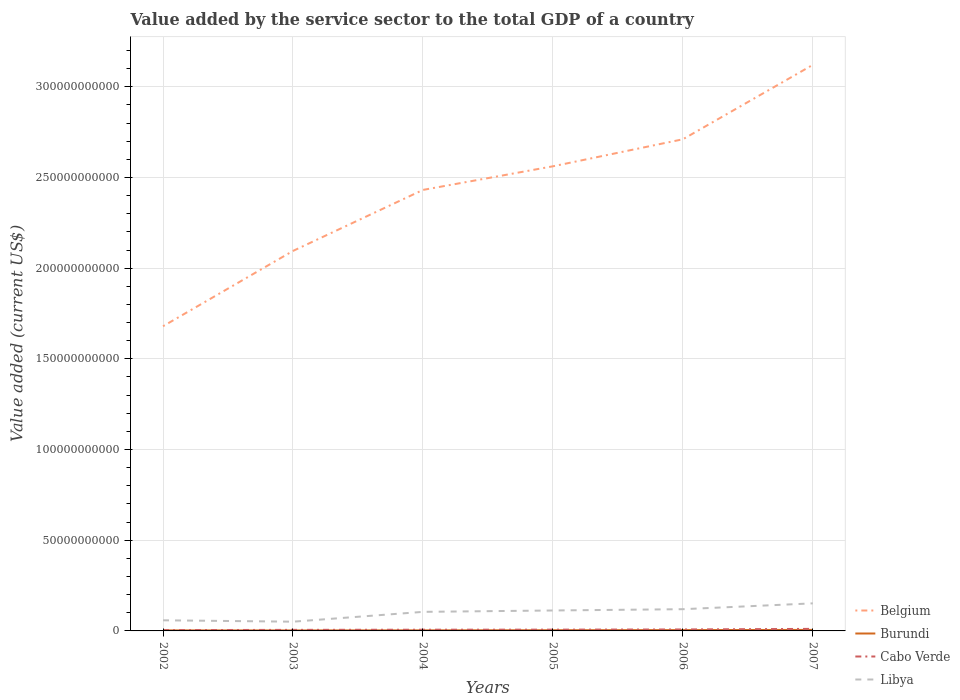Across all years, what is the maximum value added by the service sector to the total GDP in Cabo Verde?
Keep it short and to the point. 4.38e+08. What is the total value added by the service sector to the total GDP in Cabo Verde in the graph?
Offer a terse response. -3.30e+07. What is the difference between the highest and the second highest value added by the service sector to the total GDP in Libya?
Offer a terse response. 1.01e+1. What is the difference between the highest and the lowest value added by the service sector to the total GDP in Belgium?
Your answer should be compact. 3. How many lines are there?
Your answer should be compact. 4. How many years are there in the graph?
Your answer should be very brief. 6. What is the difference between two consecutive major ticks on the Y-axis?
Give a very brief answer. 5.00e+1. Does the graph contain grids?
Provide a succinct answer. Yes. How many legend labels are there?
Give a very brief answer. 4. What is the title of the graph?
Offer a terse response. Value added by the service sector to the total GDP of a country. Does "Chile" appear as one of the legend labels in the graph?
Your answer should be very brief. No. What is the label or title of the X-axis?
Provide a short and direct response. Years. What is the label or title of the Y-axis?
Your answer should be compact. Value added (current US$). What is the Value added (current US$) of Belgium in 2002?
Give a very brief answer. 1.68e+11. What is the Value added (current US$) in Burundi in 2002?
Provide a short and direct response. 2.93e+08. What is the Value added (current US$) of Cabo Verde in 2002?
Provide a short and direct response. 4.38e+08. What is the Value added (current US$) in Libya in 2002?
Provide a short and direct response. 5.86e+09. What is the Value added (current US$) of Belgium in 2003?
Your answer should be very brief. 2.10e+11. What is the Value added (current US$) in Burundi in 2003?
Ensure brevity in your answer.  2.65e+08. What is the Value added (current US$) in Cabo Verde in 2003?
Offer a terse response. 5.81e+08. What is the Value added (current US$) in Libya in 2003?
Keep it short and to the point. 5.09e+09. What is the Value added (current US$) of Belgium in 2004?
Your answer should be very brief. 2.43e+11. What is the Value added (current US$) in Burundi in 2004?
Provide a succinct answer. 3.11e+08. What is the Value added (current US$) of Cabo Verde in 2004?
Your answer should be compact. 6.65e+08. What is the Value added (current US$) of Libya in 2004?
Your answer should be very brief. 1.05e+1. What is the Value added (current US$) in Belgium in 2005?
Offer a very short reply. 2.56e+11. What is the Value added (current US$) in Burundi in 2005?
Provide a short and direct response. 3.80e+08. What is the Value added (current US$) of Cabo Verde in 2005?
Your answer should be compact. 6.98e+08. What is the Value added (current US$) in Libya in 2005?
Provide a short and direct response. 1.13e+1. What is the Value added (current US$) in Belgium in 2006?
Ensure brevity in your answer.  2.71e+11. What is the Value added (current US$) of Burundi in 2006?
Give a very brief answer. 4.54e+08. What is the Value added (current US$) in Cabo Verde in 2006?
Offer a terse response. 8.04e+08. What is the Value added (current US$) in Libya in 2006?
Provide a succinct answer. 1.20e+1. What is the Value added (current US$) of Belgium in 2007?
Provide a succinct answer. 3.12e+11. What is the Value added (current US$) in Burundi in 2007?
Offer a terse response. 5.57e+08. What is the Value added (current US$) of Cabo Verde in 2007?
Your response must be concise. 1.13e+09. What is the Value added (current US$) of Libya in 2007?
Provide a succinct answer. 1.52e+1. Across all years, what is the maximum Value added (current US$) in Belgium?
Give a very brief answer. 3.12e+11. Across all years, what is the maximum Value added (current US$) of Burundi?
Ensure brevity in your answer.  5.57e+08. Across all years, what is the maximum Value added (current US$) in Cabo Verde?
Offer a terse response. 1.13e+09. Across all years, what is the maximum Value added (current US$) of Libya?
Provide a succinct answer. 1.52e+1. Across all years, what is the minimum Value added (current US$) in Belgium?
Ensure brevity in your answer.  1.68e+11. Across all years, what is the minimum Value added (current US$) in Burundi?
Provide a short and direct response. 2.65e+08. Across all years, what is the minimum Value added (current US$) of Cabo Verde?
Provide a short and direct response. 4.38e+08. Across all years, what is the minimum Value added (current US$) of Libya?
Provide a succinct answer. 5.09e+09. What is the total Value added (current US$) in Belgium in the graph?
Keep it short and to the point. 1.46e+12. What is the total Value added (current US$) in Burundi in the graph?
Provide a succinct answer. 2.26e+09. What is the total Value added (current US$) in Cabo Verde in the graph?
Offer a very short reply. 4.31e+09. What is the total Value added (current US$) of Libya in the graph?
Offer a very short reply. 5.99e+1. What is the difference between the Value added (current US$) in Belgium in 2002 and that in 2003?
Offer a very short reply. -4.15e+1. What is the difference between the Value added (current US$) of Burundi in 2002 and that in 2003?
Make the answer very short. 2.76e+07. What is the difference between the Value added (current US$) of Cabo Verde in 2002 and that in 2003?
Make the answer very short. -1.42e+08. What is the difference between the Value added (current US$) in Libya in 2002 and that in 2003?
Give a very brief answer. 7.65e+08. What is the difference between the Value added (current US$) of Belgium in 2002 and that in 2004?
Your answer should be very brief. -7.52e+1. What is the difference between the Value added (current US$) in Burundi in 2002 and that in 2004?
Make the answer very short. -1.79e+07. What is the difference between the Value added (current US$) of Cabo Verde in 2002 and that in 2004?
Provide a short and direct response. -2.26e+08. What is the difference between the Value added (current US$) in Libya in 2002 and that in 2004?
Offer a terse response. -4.65e+09. What is the difference between the Value added (current US$) of Belgium in 2002 and that in 2005?
Offer a terse response. -8.82e+1. What is the difference between the Value added (current US$) of Burundi in 2002 and that in 2005?
Ensure brevity in your answer.  -8.69e+07. What is the difference between the Value added (current US$) in Cabo Verde in 2002 and that in 2005?
Your response must be concise. -2.59e+08. What is the difference between the Value added (current US$) in Libya in 2002 and that in 2005?
Provide a short and direct response. -5.41e+09. What is the difference between the Value added (current US$) of Belgium in 2002 and that in 2006?
Ensure brevity in your answer.  -1.03e+11. What is the difference between the Value added (current US$) in Burundi in 2002 and that in 2006?
Your response must be concise. -1.61e+08. What is the difference between the Value added (current US$) in Cabo Verde in 2002 and that in 2006?
Give a very brief answer. -3.66e+08. What is the difference between the Value added (current US$) of Libya in 2002 and that in 2006?
Offer a very short reply. -6.12e+09. What is the difference between the Value added (current US$) of Belgium in 2002 and that in 2007?
Ensure brevity in your answer.  -1.44e+11. What is the difference between the Value added (current US$) of Burundi in 2002 and that in 2007?
Provide a short and direct response. -2.64e+08. What is the difference between the Value added (current US$) of Cabo Verde in 2002 and that in 2007?
Offer a terse response. -6.91e+08. What is the difference between the Value added (current US$) of Libya in 2002 and that in 2007?
Provide a succinct answer. -9.34e+09. What is the difference between the Value added (current US$) in Belgium in 2003 and that in 2004?
Give a very brief answer. -3.36e+1. What is the difference between the Value added (current US$) in Burundi in 2003 and that in 2004?
Ensure brevity in your answer.  -4.56e+07. What is the difference between the Value added (current US$) in Cabo Verde in 2003 and that in 2004?
Give a very brief answer. -8.42e+07. What is the difference between the Value added (current US$) in Libya in 2003 and that in 2004?
Offer a very short reply. -5.42e+09. What is the difference between the Value added (current US$) of Belgium in 2003 and that in 2005?
Provide a succinct answer. -4.67e+1. What is the difference between the Value added (current US$) of Burundi in 2003 and that in 2005?
Make the answer very short. -1.15e+08. What is the difference between the Value added (current US$) in Cabo Verde in 2003 and that in 2005?
Your answer should be very brief. -1.17e+08. What is the difference between the Value added (current US$) of Libya in 2003 and that in 2005?
Keep it short and to the point. -6.18e+09. What is the difference between the Value added (current US$) of Belgium in 2003 and that in 2006?
Offer a terse response. -6.16e+1. What is the difference between the Value added (current US$) in Burundi in 2003 and that in 2006?
Provide a short and direct response. -1.89e+08. What is the difference between the Value added (current US$) of Cabo Verde in 2003 and that in 2006?
Your answer should be compact. -2.24e+08. What is the difference between the Value added (current US$) in Libya in 2003 and that in 2006?
Provide a short and direct response. -6.89e+09. What is the difference between the Value added (current US$) in Belgium in 2003 and that in 2007?
Your answer should be compact. -1.03e+11. What is the difference between the Value added (current US$) in Burundi in 2003 and that in 2007?
Your response must be concise. -2.91e+08. What is the difference between the Value added (current US$) in Cabo Verde in 2003 and that in 2007?
Provide a succinct answer. -5.48e+08. What is the difference between the Value added (current US$) in Libya in 2003 and that in 2007?
Provide a succinct answer. -1.01e+1. What is the difference between the Value added (current US$) of Belgium in 2004 and that in 2005?
Make the answer very short. -1.30e+1. What is the difference between the Value added (current US$) of Burundi in 2004 and that in 2005?
Provide a short and direct response. -6.90e+07. What is the difference between the Value added (current US$) in Cabo Verde in 2004 and that in 2005?
Make the answer very short. -3.30e+07. What is the difference between the Value added (current US$) in Libya in 2004 and that in 2005?
Offer a very short reply. -7.60e+08. What is the difference between the Value added (current US$) of Belgium in 2004 and that in 2006?
Your response must be concise. -2.79e+1. What is the difference between the Value added (current US$) of Burundi in 2004 and that in 2006?
Make the answer very short. -1.43e+08. What is the difference between the Value added (current US$) in Cabo Verde in 2004 and that in 2006?
Provide a succinct answer. -1.39e+08. What is the difference between the Value added (current US$) in Libya in 2004 and that in 2006?
Provide a short and direct response. -1.47e+09. What is the difference between the Value added (current US$) of Belgium in 2004 and that in 2007?
Provide a short and direct response. -6.90e+1. What is the difference between the Value added (current US$) of Burundi in 2004 and that in 2007?
Make the answer very short. -2.46e+08. What is the difference between the Value added (current US$) in Cabo Verde in 2004 and that in 2007?
Provide a succinct answer. -4.64e+08. What is the difference between the Value added (current US$) in Libya in 2004 and that in 2007?
Your answer should be very brief. -4.69e+09. What is the difference between the Value added (current US$) in Belgium in 2005 and that in 2006?
Ensure brevity in your answer.  -1.49e+1. What is the difference between the Value added (current US$) in Burundi in 2005 and that in 2006?
Ensure brevity in your answer.  -7.45e+07. What is the difference between the Value added (current US$) in Cabo Verde in 2005 and that in 2006?
Offer a very short reply. -1.06e+08. What is the difference between the Value added (current US$) of Libya in 2005 and that in 2006?
Provide a short and direct response. -7.10e+08. What is the difference between the Value added (current US$) of Belgium in 2005 and that in 2007?
Your answer should be compact. -5.59e+1. What is the difference between the Value added (current US$) of Burundi in 2005 and that in 2007?
Give a very brief answer. -1.77e+08. What is the difference between the Value added (current US$) in Cabo Verde in 2005 and that in 2007?
Give a very brief answer. -4.31e+08. What is the difference between the Value added (current US$) in Libya in 2005 and that in 2007?
Offer a terse response. -3.93e+09. What is the difference between the Value added (current US$) in Belgium in 2006 and that in 2007?
Your answer should be compact. -4.10e+1. What is the difference between the Value added (current US$) in Burundi in 2006 and that in 2007?
Give a very brief answer. -1.02e+08. What is the difference between the Value added (current US$) of Cabo Verde in 2006 and that in 2007?
Your answer should be very brief. -3.25e+08. What is the difference between the Value added (current US$) in Libya in 2006 and that in 2007?
Ensure brevity in your answer.  -3.22e+09. What is the difference between the Value added (current US$) in Belgium in 2002 and the Value added (current US$) in Burundi in 2003?
Make the answer very short. 1.68e+11. What is the difference between the Value added (current US$) of Belgium in 2002 and the Value added (current US$) of Cabo Verde in 2003?
Make the answer very short. 1.67e+11. What is the difference between the Value added (current US$) in Belgium in 2002 and the Value added (current US$) in Libya in 2003?
Your response must be concise. 1.63e+11. What is the difference between the Value added (current US$) in Burundi in 2002 and the Value added (current US$) in Cabo Verde in 2003?
Give a very brief answer. -2.88e+08. What is the difference between the Value added (current US$) of Burundi in 2002 and the Value added (current US$) of Libya in 2003?
Make the answer very short. -4.80e+09. What is the difference between the Value added (current US$) of Cabo Verde in 2002 and the Value added (current US$) of Libya in 2003?
Provide a succinct answer. -4.66e+09. What is the difference between the Value added (current US$) of Belgium in 2002 and the Value added (current US$) of Burundi in 2004?
Offer a very short reply. 1.68e+11. What is the difference between the Value added (current US$) of Belgium in 2002 and the Value added (current US$) of Cabo Verde in 2004?
Your answer should be compact. 1.67e+11. What is the difference between the Value added (current US$) of Belgium in 2002 and the Value added (current US$) of Libya in 2004?
Give a very brief answer. 1.57e+11. What is the difference between the Value added (current US$) in Burundi in 2002 and the Value added (current US$) in Cabo Verde in 2004?
Offer a very short reply. -3.72e+08. What is the difference between the Value added (current US$) in Burundi in 2002 and the Value added (current US$) in Libya in 2004?
Give a very brief answer. -1.02e+1. What is the difference between the Value added (current US$) of Cabo Verde in 2002 and the Value added (current US$) of Libya in 2004?
Make the answer very short. -1.01e+1. What is the difference between the Value added (current US$) in Belgium in 2002 and the Value added (current US$) in Burundi in 2005?
Make the answer very short. 1.68e+11. What is the difference between the Value added (current US$) of Belgium in 2002 and the Value added (current US$) of Cabo Verde in 2005?
Ensure brevity in your answer.  1.67e+11. What is the difference between the Value added (current US$) of Belgium in 2002 and the Value added (current US$) of Libya in 2005?
Your response must be concise. 1.57e+11. What is the difference between the Value added (current US$) in Burundi in 2002 and the Value added (current US$) in Cabo Verde in 2005?
Your answer should be compact. -4.05e+08. What is the difference between the Value added (current US$) of Burundi in 2002 and the Value added (current US$) of Libya in 2005?
Ensure brevity in your answer.  -1.10e+1. What is the difference between the Value added (current US$) in Cabo Verde in 2002 and the Value added (current US$) in Libya in 2005?
Your response must be concise. -1.08e+1. What is the difference between the Value added (current US$) of Belgium in 2002 and the Value added (current US$) of Burundi in 2006?
Offer a very short reply. 1.68e+11. What is the difference between the Value added (current US$) in Belgium in 2002 and the Value added (current US$) in Cabo Verde in 2006?
Provide a short and direct response. 1.67e+11. What is the difference between the Value added (current US$) in Belgium in 2002 and the Value added (current US$) in Libya in 2006?
Your answer should be very brief. 1.56e+11. What is the difference between the Value added (current US$) in Burundi in 2002 and the Value added (current US$) in Cabo Verde in 2006?
Your answer should be compact. -5.11e+08. What is the difference between the Value added (current US$) of Burundi in 2002 and the Value added (current US$) of Libya in 2006?
Make the answer very short. -1.17e+1. What is the difference between the Value added (current US$) of Cabo Verde in 2002 and the Value added (current US$) of Libya in 2006?
Ensure brevity in your answer.  -1.15e+1. What is the difference between the Value added (current US$) of Belgium in 2002 and the Value added (current US$) of Burundi in 2007?
Give a very brief answer. 1.67e+11. What is the difference between the Value added (current US$) of Belgium in 2002 and the Value added (current US$) of Cabo Verde in 2007?
Ensure brevity in your answer.  1.67e+11. What is the difference between the Value added (current US$) in Belgium in 2002 and the Value added (current US$) in Libya in 2007?
Provide a succinct answer. 1.53e+11. What is the difference between the Value added (current US$) of Burundi in 2002 and the Value added (current US$) of Cabo Verde in 2007?
Provide a succinct answer. -8.36e+08. What is the difference between the Value added (current US$) in Burundi in 2002 and the Value added (current US$) in Libya in 2007?
Ensure brevity in your answer.  -1.49e+1. What is the difference between the Value added (current US$) in Cabo Verde in 2002 and the Value added (current US$) in Libya in 2007?
Ensure brevity in your answer.  -1.48e+1. What is the difference between the Value added (current US$) of Belgium in 2003 and the Value added (current US$) of Burundi in 2004?
Provide a short and direct response. 2.09e+11. What is the difference between the Value added (current US$) of Belgium in 2003 and the Value added (current US$) of Cabo Verde in 2004?
Make the answer very short. 2.09e+11. What is the difference between the Value added (current US$) in Belgium in 2003 and the Value added (current US$) in Libya in 2004?
Your answer should be very brief. 1.99e+11. What is the difference between the Value added (current US$) of Burundi in 2003 and the Value added (current US$) of Cabo Verde in 2004?
Provide a succinct answer. -3.99e+08. What is the difference between the Value added (current US$) in Burundi in 2003 and the Value added (current US$) in Libya in 2004?
Ensure brevity in your answer.  -1.02e+1. What is the difference between the Value added (current US$) in Cabo Verde in 2003 and the Value added (current US$) in Libya in 2004?
Make the answer very short. -9.93e+09. What is the difference between the Value added (current US$) in Belgium in 2003 and the Value added (current US$) in Burundi in 2005?
Provide a succinct answer. 2.09e+11. What is the difference between the Value added (current US$) in Belgium in 2003 and the Value added (current US$) in Cabo Verde in 2005?
Ensure brevity in your answer.  2.09e+11. What is the difference between the Value added (current US$) in Belgium in 2003 and the Value added (current US$) in Libya in 2005?
Provide a succinct answer. 1.98e+11. What is the difference between the Value added (current US$) in Burundi in 2003 and the Value added (current US$) in Cabo Verde in 2005?
Your response must be concise. -4.32e+08. What is the difference between the Value added (current US$) in Burundi in 2003 and the Value added (current US$) in Libya in 2005?
Give a very brief answer. -1.10e+1. What is the difference between the Value added (current US$) in Cabo Verde in 2003 and the Value added (current US$) in Libya in 2005?
Give a very brief answer. -1.07e+1. What is the difference between the Value added (current US$) in Belgium in 2003 and the Value added (current US$) in Burundi in 2006?
Your answer should be compact. 2.09e+11. What is the difference between the Value added (current US$) in Belgium in 2003 and the Value added (current US$) in Cabo Verde in 2006?
Ensure brevity in your answer.  2.09e+11. What is the difference between the Value added (current US$) of Belgium in 2003 and the Value added (current US$) of Libya in 2006?
Keep it short and to the point. 1.98e+11. What is the difference between the Value added (current US$) of Burundi in 2003 and the Value added (current US$) of Cabo Verde in 2006?
Provide a short and direct response. -5.39e+08. What is the difference between the Value added (current US$) of Burundi in 2003 and the Value added (current US$) of Libya in 2006?
Your answer should be compact. -1.17e+1. What is the difference between the Value added (current US$) of Cabo Verde in 2003 and the Value added (current US$) of Libya in 2006?
Your response must be concise. -1.14e+1. What is the difference between the Value added (current US$) of Belgium in 2003 and the Value added (current US$) of Burundi in 2007?
Your answer should be compact. 2.09e+11. What is the difference between the Value added (current US$) of Belgium in 2003 and the Value added (current US$) of Cabo Verde in 2007?
Offer a terse response. 2.08e+11. What is the difference between the Value added (current US$) of Belgium in 2003 and the Value added (current US$) of Libya in 2007?
Provide a short and direct response. 1.94e+11. What is the difference between the Value added (current US$) of Burundi in 2003 and the Value added (current US$) of Cabo Verde in 2007?
Your response must be concise. -8.64e+08. What is the difference between the Value added (current US$) of Burundi in 2003 and the Value added (current US$) of Libya in 2007?
Your response must be concise. -1.49e+1. What is the difference between the Value added (current US$) of Cabo Verde in 2003 and the Value added (current US$) of Libya in 2007?
Make the answer very short. -1.46e+1. What is the difference between the Value added (current US$) in Belgium in 2004 and the Value added (current US$) in Burundi in 2005?
Keep it short and to the point. 2.43e+11. What is the difference between the Value added (current US$) in Belgium in 2004 and the Value added (current US$) in Cabo Verde in 2005?
Keep it short and to the point. 2.42e+11. What is the difference between the Value added (current US$) in Belgium in 2004 and the Value added (current US$) in Libya in 2005?
Make the answer very short. 2.32e+11. What is the difference between the Value added (current US$) in Burundi in 2004 and the Value added (current US$) in Cabo Verde in 2005?
Give a very brief answer. -3.87e+08. What is the difference between the Value added (current US$) in Burundi in 2004 and the Value added (current US$) in Libya in 2005?
Provide a short and direct response. -1.10e+1. What is the difference between the Value added (current US$) of Cabo Verde in 2004 and the Value added (current US$) of Libya in 2005?
Offer a terse response. -1.06e+1. What is the difference between the Value added (current US$) of Belgium in 2004 and the Value added (current US$) of Burundi in 2006?
Ensure brevity in your answer.  2.43e+11. What is the difference between the Value added (current US$) of Belgium in 2004 and the Value added (current US$) of Cabo Verde in 2006?
Provide a succinct answer. 2.42e+11. What is the difference between the Value added (current US$) of Belgium in 2004 and the Value added (current US$) of Libya in 2006?
Make the answer very short. 2.31e+11. What is the difference between the Value added (current US$) of Burundi in 2004 and the Value added (current US$) of Cabo Verde in 2006?
Your answer should be compact. -4.93e+08. What is the difference between the Value added (current US$) in Burundi in 2004 and the Value added (current US$) in Libya in 2006?
Your answer should be compact. -1.17e+1. What is the difference between the Value added (current US$) in Cabo Verde in 2004 and the Value added (current US$) in Libya in 2006?
Ensure brevity in your answer.  -1.13e+1. What is the difference between the Value added (current US$) in Belgium in 2004 and the Value added (current US$) in Burundi in 2007?
Your answer should be compact. 2.43e+11. What is the difference between the Value added (current US$) in Belgium in 2004 and the Value added (current US$) in Cabo Verde in 2007?
Keep it short and to the point. 2.42e+11. What is the difference between the Value added (current US$) of Belgium in 2004 and the Value added (current US$) of Libya in 2007?
Provide a succinct answer. 2.28e+11. What is the difference between the Value added (current US$) of Burundi in 2004 and the Value added (current US$) of Cabo Verde in 2007?
Make the answer very short. -8.18e+08. What is the difference between the Value added (current US$) in Burundi in 2004 and the Value added (current US$) in Libya in 2007?
Provide a succinct answer. -1.49e+1. What is the difference between the Value added (current US$) in Cabo Verde in 2004 and the Value added (current US$) in Libya in 2007?
Keep it short and to the point. -1.45e+1. What is the difference between the Value added (current US$) of Belgium in 2005 and the Value added (current US$) of Burundi in 2006?
Make the answer very short. 2.56e+11. What is the difference between the Value added (current US$) of Belgium in 2005 and the Value added (current US$) of Cabo Verde in 2006?
Give a very brief answer. 2.55e+11. What is the difference between the Value added (current US$) in Belgium in 2005 and the Value added (current US$) in Libya in 2006?
Provide a succinct answer. 2.44e+11. What is the difference between the Value added (current US$) in Burundi in 2005 and the Value added (current US$) in Cabo Verde in 2006?
Keep it short and to the point. -4.24e+08. What is the difference between the Value added (current US$) in Burundi in 2005 and the Value added (current US$) in Libya in 2006?
Your answer should be very brief. -1.16e+1. What is the difference between the Value added (current US$) of Cabo Verde in 2005 and the Value added (current US$) of Libya in 2006?
Offer a very short reply. -1.13e+1. What is the difference between the Value added (current US$) in Belgium in 2005 and the Value added (current US$) in Burundi in 2007?
Keep it short and to the point. 2.56e+11. What is the difference between the Value added (current US$) in Belgium in 2005 and the Value added (current US$) in Cabo Verde in 2007?
Provide a succinct answer. 2.55e+11. What is the difference between the Value added (current US$) in Belgium in 2005 and the Value added (current US$) in Libya in 2007?
Ensure brevity in your answer.  2.41e+11. What is the difference between the Value added (current US$) in Burundi in 2005 and the Value added (current US$) in Cabo Verde in 2007?
Make the answer very short. -7.49e+08. What is the difference between the Value added (current US$) of Burundi in 2005 and the Value added (current US$) of Libya in 2007?
Provide a succinct answer. -1.48e+1. What is the difference between the Value added (current US$) of Cabo Verde in 2005 and the Value added (current US$) of Libya in 2007?
Your answer should be compact. -1.45e+1. What is the difference between the Value added (current US$) in Belgium in 2006 and the Value added (current US$) in Burundi in 2007?
Make the answer very short. 2.71e+11. What is the difference between the Value added (current US$) of Belgium in 2006 and the Value added (current US$) of Cabo Verde in 2007?
Your answer should be very brief. 2.70e+11. What is the difference between the Value added (current US$) in Belgium in 2006 and the Value added (current US$) in Libya in 2007?
Provide a succinct answer. 2.56e+11. What is the difference between the Value added (current US$) of Burundi in 2006 and the Value added (current US$) of Cabo Verde in 2007?
Ensure brevity in your answer.  -6.75e+08. What is the difference between the Value added (current US$) of Burundi in 2006 and the Value added (current US$) of Libya in 2007?
Your response must be concise. -1.47e+1. What is the difference between the Value added (current US$) of Cabo Verde in 2006 and the Value added (current US$) of Libya in 2007?
Offer a terse response. -1.44e+1. What is the average Value added (current US$) of Belgium per year?
Offer a very short reply. 2.43e+11. What is the average Value added (current US$) in Burundi per year?
Your response must be concise. 3.77e+08. What is the average Value added (current US$) in Cabo Verde per year?
Offer a terse response. 7.19e+08. What is the average Value added (current US$) of Libya per year?
Offer a terse response. 9.99e+09. In the year 2002, what is the difference between the Value added (current US$) of Belgium and Value added (current US$) of Burundi?
Make the answer very short. 1.68e+11. In the year 2002, what is the difference between the Value added (current US$) in Belgium and Value added (current US$) in Cabo Verde?
Give a very brief answer. 1.68e+11. In the year 2002, what is the difference between the Value added (current US$) in Belgium and Value added (current US$) in Libya?
Offer a very short reply. 1.62e+11. In the year 2002, what is the difference between the Value added (current US$) of Burundi and Value added (current US$) of Cabo Verde?
Keep it short and to the point. -1.45e+08. In the year 2002, what is the difference between the Value added (current US$) in Burundi and Value added (current US$) in Libya?
Offer a terse response. -5.57e+09. In the year 2002, what is the difference between the Value added (current US$) in Cabo Verde and Value added (current US$) in Libya?
Offer a very short reply. -5.42e+09. In the year 2003, what is the difference between the Value added (current US$) in Belgium and Value added (current US$) in Burundi?
Provide a succinct answer. 2.09e+11. In the year 2003, what is the difference between the Value added (current US$) of Belgium and Value added (current US$) of Cabo Verde?
Your answer should be very brief. 2.09e+11. In the year 2003, what is the difference between the Value added (current US$) of Belgium and Value added (current US$) of Libya?
Ensure brevity in your answer.  2.04e+11. In the year 2003, what is the difference between the Value added (current US$) of Burundi and Value added (current US$) of Cabo Verde?
Keep it short and to the point. -3.15e+08. In the year 2003, what is the difference between the Value added (current US$) in Burundi and Value added (current US$) in Libya?
Your answer should be compact. -4.83e+09. In the year 2003, what is the difference between the Value added (current US$) of Cabo Verde and Value added (current US$) of Libya?
Keep it short and to the point. -4.51e+09. In the year 2004, what is the difference between the Value added (current US$) in Belgium and Value added (current US$) in Burundi?
Keep it short and to the point. 2.43e+11. In the year 2004, what is the difference between the Value added (current US$) of Belgium and Value added (current US$) of Cabo Verde?
Keep it short and to the point. 2.42e+11. In the year 2004, what is the difference between the Value added (current US$) in Belgium and Value added (current US$) in Libya?
Give a very brief answer. 2.33e+11. In the year 2004, what is the difference between the Value added (current US$) in Burundi and Value added (current US$) in Cabo Verde?
Make the answer very short. -3.54e+08. In the year 2004, what is the difference between the Value added (current US$) in Burundi and Value added (current US$) in Libya?
Offer a terse response. -1.02e+1. In the year 2004, what is the difference between the Value added (current US$) of Cabo Verde and Value added (current US$) of Libya?
Make the answer very short. -9.85e+09. In the year 2005, what is the difference between the Value added (current US$) of Belgium and Value added (current US$) of Burundi?
Offer a very short reply. 2.56e+11. In the year 2005, what is the difference between the Value added (current US$) of Belgium and Value added (current US$) of Cabo Verde?
Give a very brief answer. 2.55e+11. In the year 2005, what is the difference between the Value added (current US$) of Belgium and Value added (current US$) of Libya?
Keep it short and to the point. 2.45e+11. In the year 2005, what is the difference between the Value added (current US$) of Burundi and Value added (current US$) of Cabo Verde?
Provide a succinct answer. -3.18e+08. In the year 2005, what is the difference between the Value added (current US$) in Burundi and Value added (current US$) in Libya?
Give a very brief answer. -1.09e+1. In the year 2005, what is the difference between the Value added (current US$) in Cabo Verde and Value added (current US$) in Libya?
Make the answer very short. -1.06e+1. In the year 2006, what is the difference between the Value added (current US$) in Belgium and Value added (current US$) in Burundi?
Provide a succinct answer. 2.71e+11. In the year 2006, what is the difference between the Value added (current US$) in Belgium and Value added (current US$) in Cabo Verde?
Your response must be concise. 2.70e+11. In the year 2006, what is the difference between the Value added (current US$) of Belgium and Value added (current US$) of Libya?
Keep it short and to the point. 2.59e+11. In the year 2006, what is the difference between the Value added (current US$) in Burundi and Value added (current US$) in Cabo Verde?
Your answer should be compact. -3.50e+08. In the year 2006, what is the difference between the Value added (current US$) of Burundi and Value added (current US$) of Libya?
Make the answer very short. -1.15e+1. In the year 2006, what is the difference between the Value added (current US$) in Cabo Verde and Value added (current US$) in Libya?
Provide a short and direct response. -1.12e+1. In the year 2007, what is the difference between the Value added (current US$) of Belgium and Value added (current US$) of Burundi?
Provide a succinct answer. 3.12e+11. In the year 2007, what is the difference between the Value added (current US$) in Belgium and Value added (current US$) in Cabo Verde?
Provide a short and direct response. 3.11e+11. In the year 2007, what is the difference between the Value added (current US$) of Belgium and Value added (current US$) of Libya?
Give a very brief answer. 2.97e+11. In the year 2007, what is the difference between the Value added (current US$) of Burundi and Value added (current US$) of Cabo Verde?
Ensure brevity in your answer.  -5.72e+08. In the year 2007, what is the difference between the Value added (current US$) of Burundi and Value added (current US$) of Libya?
Offer a very short reply. -1.46e+1. In the year 2007, what is the difference between the Value added (current US$) in Cabo Verde and Value added (current US$) in Libya?
Your answer should be compact. -1.41e+1. What is the ratio of the Value added (current US$) of Belgium in 2002 to that in 2003?
Make the answer very short. 0.8. What is the ratio of the Value added (current US$) of Burundi in 2002 to that in 2003?
Make the answer very short. 1.1. What is the ratio of the Value added (current US$) in Cabo Verde in 2002 to that in 2003?
Offer a terse response. 0.76. What is the ratio of the Value added (current US$) of Libya in 2002 to that in 2003?
Your response must be concise. 1.15. What is the ratio of the Value added (current US$) of Belgium in 2002 to that in 2004?
Your answer should be very brief. 0.69. What is the ratio of the Value added (current US$) of Burundi in 2002 to that in 2004?
Keep it short and to the point. 0.94. What is the ratio of the Value added (current US$) of Cabo Verde in 2002 to that in 2004?
Offer a very short reply. 0.66. What is the ratio of the Value added (current US$) of Libya in 2002 to that in 2004?
Your answer should be compact. 0.56. What is the ratio of the Value added (current US$) of Belgium in 2002 to that in 2005?
Make the answer very short. 0.66. What is the ratio of the Value added (current US$) of Burundi in 2002 to that in 2005?
Your response must be concise. 0.77. What is the ratio of the Value added (current US$) of Cabo Verde in 2002 to that in 2005?
Keep it short and to the point. 0.63. What is the ratio of the Value added (current US$) in Libya in 2002 to that in 2005?
Your answer should be very brief. 0.52. What is the ratio of the Value added (current US$) of Belgium in 2002 to that in 2006?
Provide a succinct answer. 0.62. What is the ratio of the Value added (current US$) in Burundi in 2002 to that in 2006?
Offer a very short reply. 0.64. What is the ratio of the Value added (current US$) in Cabo Verde in 2002 to that in 2006?
Your answer should be very brief. 0.55. What is the ratio of the Value added (current US$) of Libya in 2002 to that in 2006?
Provide a short and direct response. 0.49. What is the ratio of the Value added (current US$) in Belgium in 2002 to that in 2007?
Your answer should be compact. 0.54. What is the ratio of the Value added (current US$) of Burundi in 2002 to that in 2007?
Provide a short and direct response. 0.53. What is the ratio of the Value added (current US$) in Cabo Verde in 2002 to that in 2007?
Provide a succinct answer. 0.39. What is the ratio of the Value added (current US$) of Libya in 2002 to that in 2007?
Your answer should be very brief. 0.39. What is the ratio of the Value added (current US$) of Belgium in 2003 to that in 2004?
Offer a very short reply. 0.86. What is the ratio of the Value added (current US$) in Burundi in 2003 to that in 2004?
Make the answer very short. 0.85. What is the ratio of the Value added (current US$) of Cabo Verde in 2003 to that in 2004?
Provide a short and direct response. 0.87. What is the ratio of the Value added (current US$) of Libya in 2003 to that in 2004?
Your answer should be compact. 0.48. What is the ratio of the Value added (current US$) in Belgium in 2003 to that in 2005?
Offer a terse response. 0.82. What is the ratio of the Value added (current US$) of Burundi in 2003 to that in 2005?
Offer a terse response. 0.7. What is the ratio of the Value added (current US$) of Cabo Verde in 2003 to that in 2005?
Offer a terse response. 0.83. What is the ratio of the Value added (current US$) of Libya in 2003 to that in 2005?
Give a very brief answer. 0.45. What is the ratio of the Value added (current US$) of Belgium in 2003 to that in 2006?
Provide a succinct answer. 0.77. What is the ratio of the Value added (current US$) in Burundi in 2003 to that in 2006?
Provide a succinct answer. 0.58. What is the ratio of the Value added (current US$) in Cabo Verde in 2003 to that in 2006?
Make the answer very short. 0.72. What is the ratio of the Value added (current US$) in Libya in 2003 to that in 2006?
Give a very brief answer. 0.43. What is the ratio of the Value added (current US$) of Belgium in 2003 to that in 2007?
Your answer should be compact. 0.67. What is the ratio of the Value added (current US$) in Burundi in 2003 to that in 2007?
Make the answer very short. 0.48. What is the ratio of the Value added (current US$) in Cabo Verde in 2003 to that in 2007?
Offer a terse response. 0.51. What is the ratio of the Value added (current US$) in Libya in 2003 to that in 2007?
Ensure brevity in your answer.  0.34. What is the ratio of the Value added (current US$) in Belgium in 2004 to that in 2005?
Give a very brief answer. 0.95. What is the ratio of the Value added (current US$) in Burundi in 2004 to that in 2005?
Keep it short and to the point. 0.82. What is the ratio of the Value added (current US$) in Cabo Verde in 2004 to that in 2005?
Ensure brevity in your answer.  0.95. What is the ratio of the Value added (current US$) in Libya in 2004 to that in 2005?
Ensure brevity in your answer.  0.93. What is the ratio of the Value added (current US$) of Belgium in 2004 to that in 2006?
Your response must be concise. 0.9. What is the ratio of the Value added (current US$) of Burundi in 2004 to that in 2006?
Your answer should be compact. 0.68. What is the ratio of the Value added (current US$) in Cabo Verde in 2004 to that in 2006?
Offer a terse response. 0.83. What is the ratio of the Value added (current US$) of Libya in 2004 to that in 2006?
Give a very brief answer. 0.88. What is the ratio of the Value added (current US$) of Belgium in 2004 to that in 2007?
Give a very brief answer. 0.78. What is the ratio of the Value added (current US$) in Burundi in 2004 to that in 2007?
Keep it short and to the point. 0.56. What is the ratio of the Value added (current US$) of Cabo Verde in 2004 to that in 2007?
Ensure brevity in your answer.  0.59. What is the ratio of the Value added (current US$) of Libya in 2004 to that in 2007?
Your response must be concise. 0.69. What is the ratio of the Value added (current US$) in Belgium in 2005 to that in 2006?
Keep it short and to the point. 0.94. What is the ratio of the Value added (current US$) in Burundi in 2005 to that in 2006?
Give a very brief answer. 0.84. What is the ratio of the Value added (current US$) in Cabo Verde in 2005 to that in 2006?
Your response must be concise. 0.87. What is the ratio of the Value added (current US$) of Libya in 2005 to that in 2006?
Provide a short and direct response. 0.94. What is the ratio of the Value added (current US$) of Belgium in 2005 to that in 2007?
Offer a terse response. 0.82. What is the ratio of the Value added (current US$) in Burundi in 2005 to that in 2007?
Make the answer very short. 0.68. What is the ratio of the Value added (current US$) in Cabo Verde in 2005 to that in 2007?
Your answer should be very brief. 0.62. What is the ratio of the Value added (current US$) of Libya in 2005 to that in 2007?
Provide a short and direct response. 0.74. What is the ratio of the Value added (current US$) in Belgium in 2006 to that in 2007?
Provide a short and direct response. 0.87. What is the ratio of the Value added (current US$) of Burundi in 2006 to that in 2007?
Your answer should be very brief. 0.82. What is the ratio of the Value added (current US$) in Cabo Verde in 2006 to that in 2007?
Offer a terse response. 0.71. What is the ratio of the Value added (current US$) in Libya in 2006 to that in 2007?
Offer a very short reply. 0.79. What is the difference between the highest and the second highest Value added (current US$) of Belgium?
Provide a short and direct response. 4.10e+1. What is the difference between the highest and the second highest Value added (current US$) in Burundi?
Offer a terse response. 1.02e+08. What is the difference between the highest and the second highest Value added (current US$) in Cabo Verde?
Offer a terse response. 3.25e+08. What is the difference between the highest and the second highest Value added (current US$) of Libya?
Your answer should be very brief. 3.22e+09. What is the difference between the highest and the lowest Value added (current US$) of Belgium?
Provide a succinct answer. 1.44e+11. What is the difference between the highest and the lowest Value added (current US$) in Burundi?
Offer a terse response. 2.91e+08. What is the difference between the highest and the lowest Value added (current US$) in Cabo Verde?
Keep it short and to the point. 6.91e+08. What is the difference between the highest and the lowest Value added (current US$) of Libya?
Your answer should be compact. 1.01e+1. 